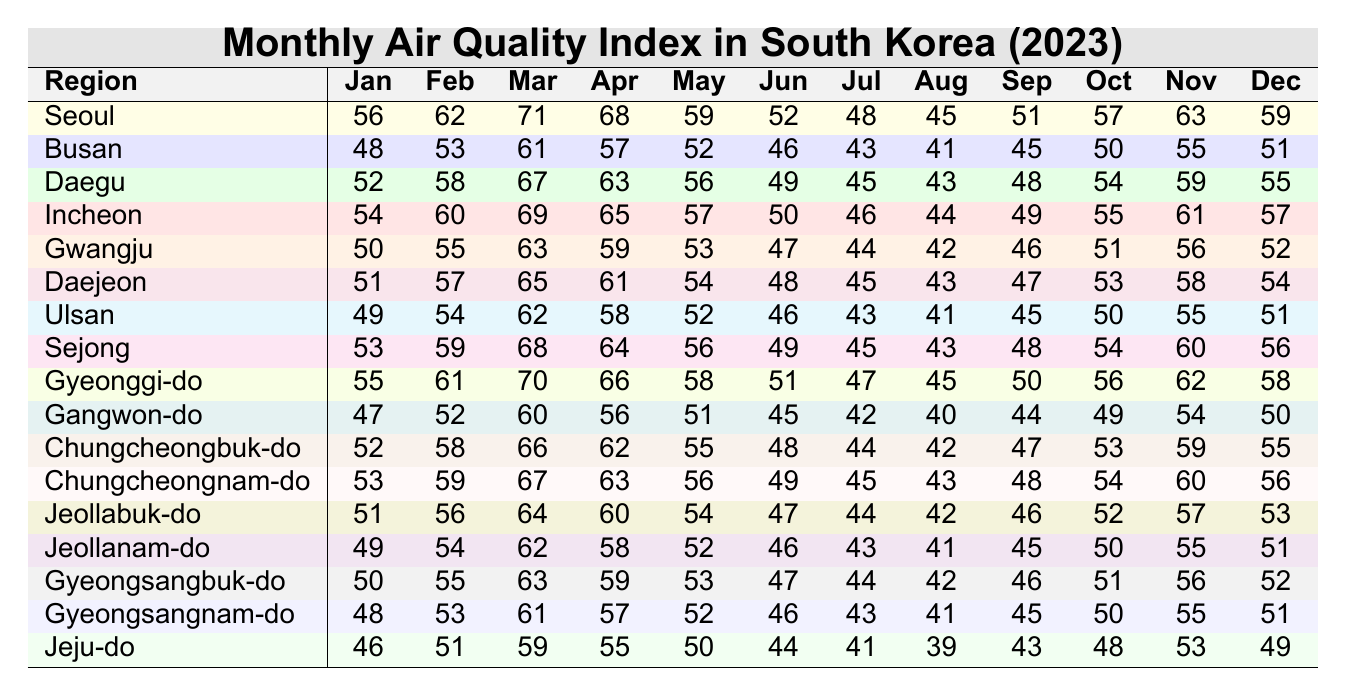What was the air quality index in Seoul in March? The table provides the value for Seoul in March, which is listed directly as 71.
Answer: 71 Which region had the lowest air quality index in August? By checking the values for August across all regions, Ulsan has the lowest value of 41.
Answer: Ulsan What is the average air quality index for Gyeonggi-do across the year? Summing the values for Gyeonggi-do: (55 + 61 + 70 + 66 + 58 + 51 + 47 + 45 + 50 + 56 + 62 + 58) =  686. There are 12 months, resulting in an average of 686/12 ≈ 57.17.
Answer: 57.17 Did the air quality index in Busan decrease from May to July? The index for Busan in May is 52 and in July is 43, so it decreased by 9 points.
Answer: Yes What is the difference in air quality index between Incheon and Daegu in October? Incheon has a value of 55 and Daegu has a value of 54 in October. The difference is 55 - 54 = 1.
Answer: 1 Which region showed the most improvement from June to August? Comparing the differences, Seoul decreased from 52 to 45 (a change of -7), Busan decreased from 46 to 41 (a change of -5), Daegu decreased from 49 to 43 (a change of -6), and so on. Gwangju has the smallest decrease of -5. Therefore, Gwangju showed the least improvement.
Answer: Gwangju What was the air quality index trend in Jeju-do for the year? A review of the values shows a general decline: 46, 51, 59, 55, 50, 44, 41, 39, 43, 48, 53, 49. The overall trend appears to be a slight drop after peaking in March.
Answer: Slight decline Did Chungcheongbuk-do have a higher air quality index than Chungcheongnam-do in April? The values for April are both 62 for Chungcheongbuk-do and 63 for Chungcheongnam-do. Thus, Chungcheongbuk-do was lower.
Answer: No What is the median air quality index for all regions in June? The values in June are: 52 (Seoul), 46 (Busan), 49 (Daegu), 50 (Incheon), 47 (Gwangju), 48 (Daejeon), 46 (Ulsan), 49 (Sejong), 51 (Gyeonggi-do), 45 (Gangwon-do), 48 (Chungcheongbuk-do), 49 (Chungcheongnam-do), 47 (Jeollabuk-do), 46 (Jeollanam-do), 47 (Gyeongsangbuk-do), 46 (Gyeongsangnam-do), 44 (Jeju-do). There are 17 values, sorted they yield a median of 47.
Answer: 47 Which region had the highest air quality index in November? Comparing the values in November, Gyeonggi-do has the highest value at 62.
Answer: Gyeonggi-do 